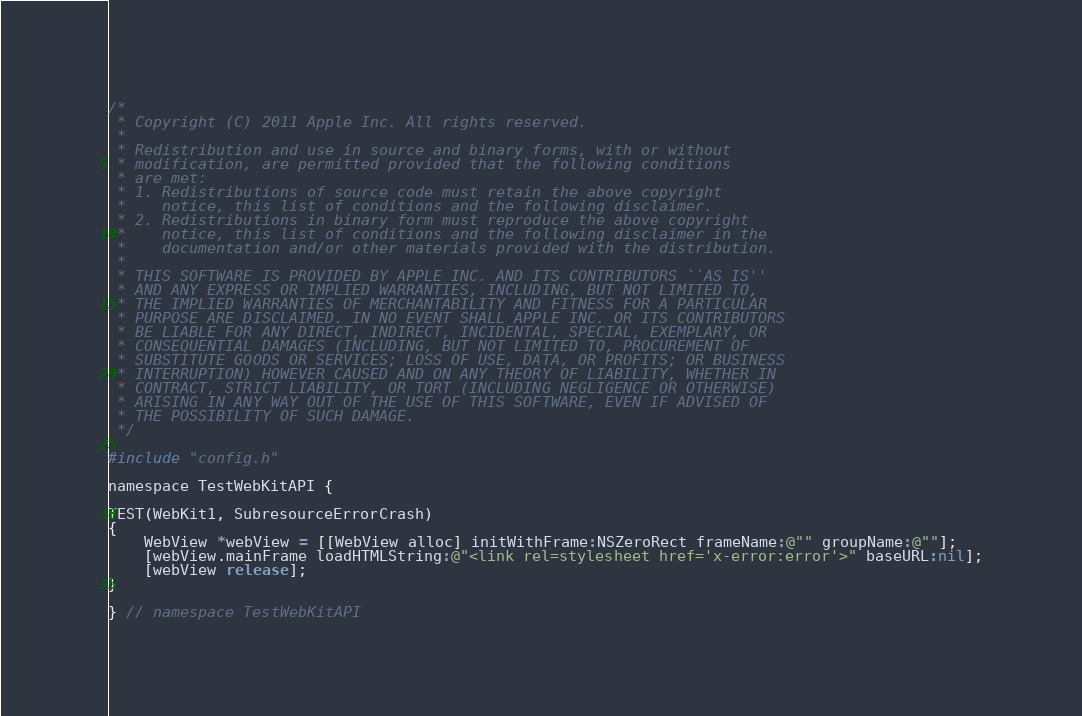<code> <loc_0><loc_0><loc_500><loc_500><_ObjectiveC_>/*
 * Copyright (C) 2011 Apple Inc. All rights reserved.
 *
 * Redistribution and use in source and binary forms, with or without
 * modification, are permitted provided that the following conditions
 * are met:
 * 1. Redistributions of source code must retain the above copyright
 *    notice, this list of conditions and the following disclaimer.
 * 2. Redistributions in binary form must reproduce the above copyright
 *    notice, this list of conditions and the following disclaimer in the
 *    documentation and/or other materials provided with the distribution.
 *
 * THIS SOFTWARE IS PROVIDED BY APPLE INC. AND ITS CONTRIBUTORS ``AS IS''
 * AND ANY EXPRESS OR IMPLIED WARRANTIES, INCLUDING, BUT NOT LIMITED TO,
 * THE IMPLIED WARRANTIES OF MERCHANTABILITY AND FITNESS FOR A PARTICULAR
 * PURPOSE ARE DISCLAIMED. IN NO EVENT SHALL APPLE INC. OR ITS CONTRIBUTORS
 * BE LIABLE FOR ANY DIRECT, INDIRECT, INCIDENTAL, SPECIAL, EXEMPLARY, OR
 * CONSEQUENTIAL DAMAGES (INCLUDING, BUT NOT LIMITED TO, PROCUREMENT OF
 * SUBSTITUTE GOODS OR SERVICES; LOSS OF USE, DATA, OR PROFITS; OR BUSINESS
 * INTERRUPTION) HOWEVER CAUSED AND ON ANY THEORY OF LIABILITY, WHETHER IN
 * CONTRACT, STRICT LIABILITY, OR TORT (INCLUDING NEGLIGENCE OR OTHERWISE)
 * ARISING IN ANY WAY OUT OF THE USE OF THIS SOFTWARE, EVEN IF ADVISED OF
 * THE POSSIBILITY OF SUCH DAMAGE.
 */

#include "config.h"

namespace TestWebKitAPI {

TEST(WebKit1, SubresourceErrorCrash)
{
    WebView *webView = [[WebView alloc] initWithFrame:NSZeroRect frameName:@"" groupName:@""];
    [webView.mainFrame loadHTMLString:@"<link rel=stylesheet href='x-error:error'>" baseURL:nil];
    [webView release];
}

} // namespace TestWebKitAPI
</code> 